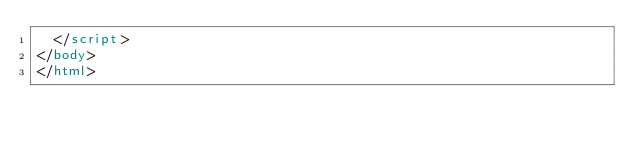Convert code to text. <code><loc_0><loc_0><loc_500><loc_500><_HTML_>  </script>
</body>
</html>

</code> 